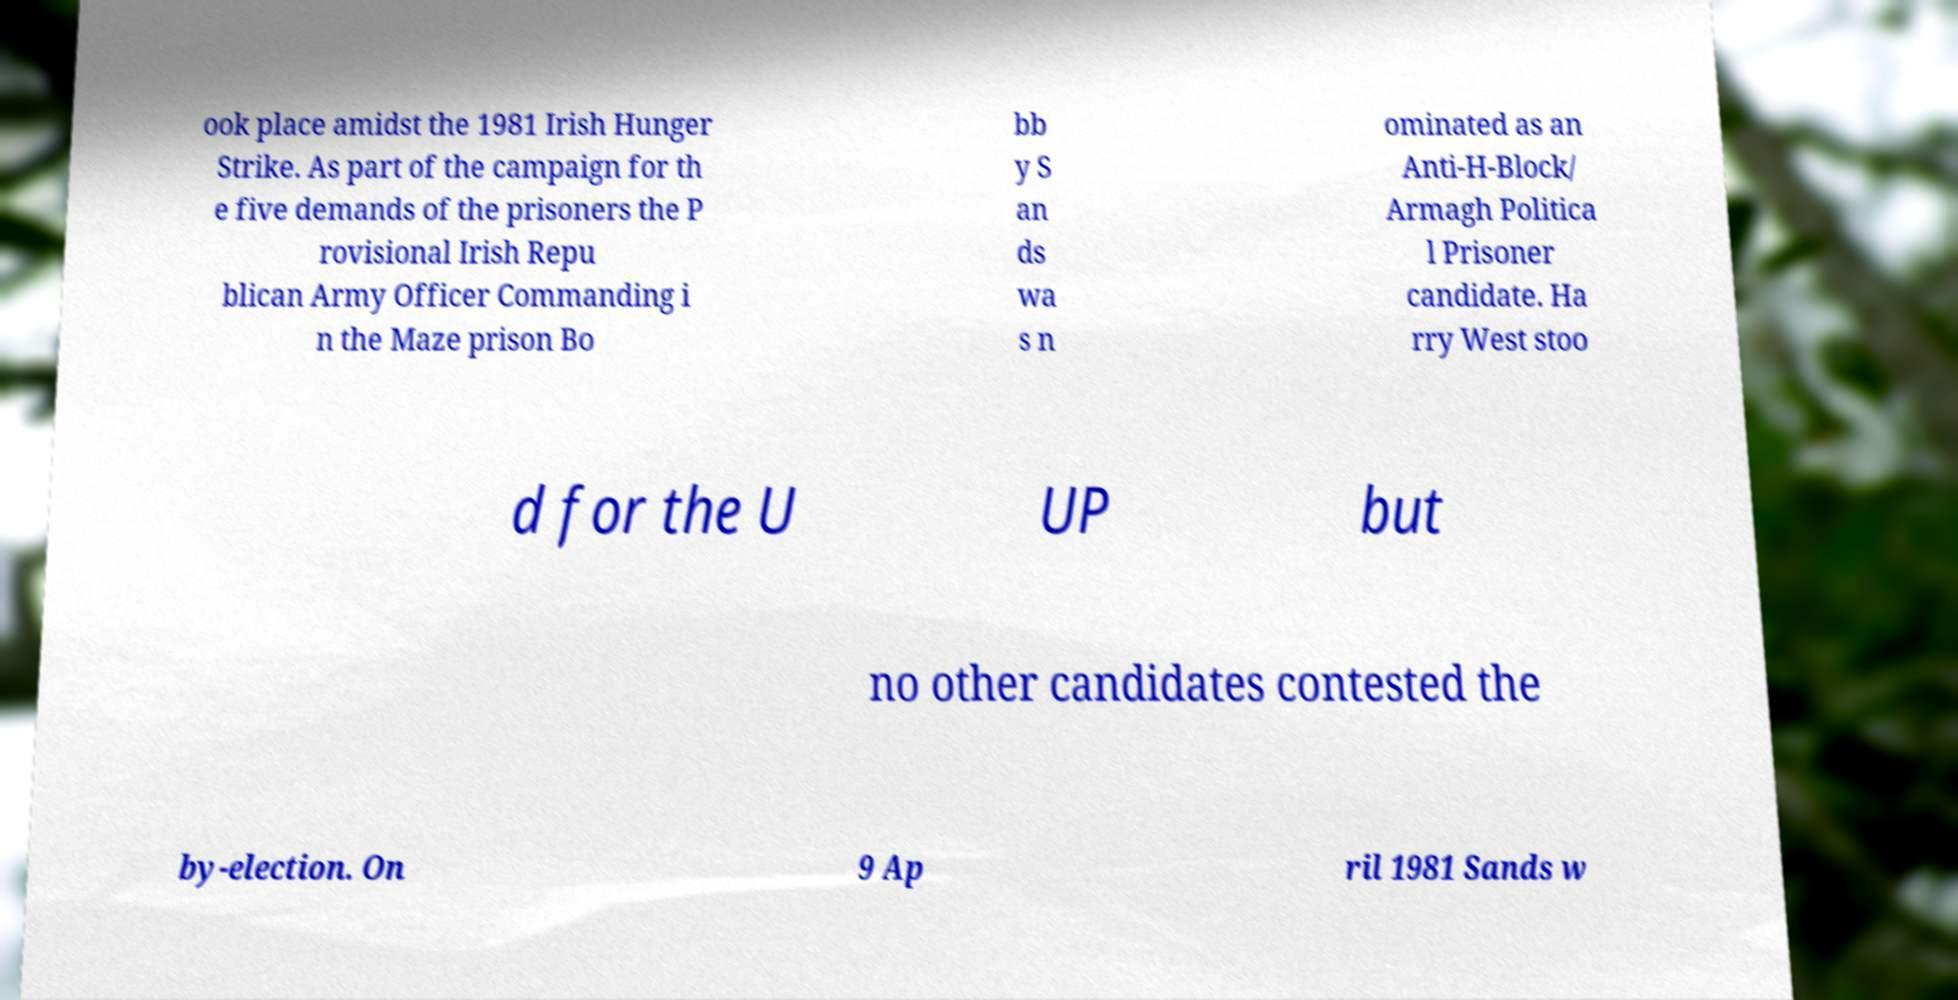For documentation purposes, I need the text within this image transcribed. Could you provide that? ook place amidst the 1981 Irish Hunger Strike. As part of the campaign for th e five demands of the prisoners the P rovisional Irish Repu blican Army Officer Commanding i n the Maze prison Bo bb y S an ds wa s n ominated as an Anti-H-Block/ Armagh Politica l Prisoner candidate. Ha rry West stoo d for the U UP but no other candidates contested the by-election. On 9 Ap ril 1981 Sands w 